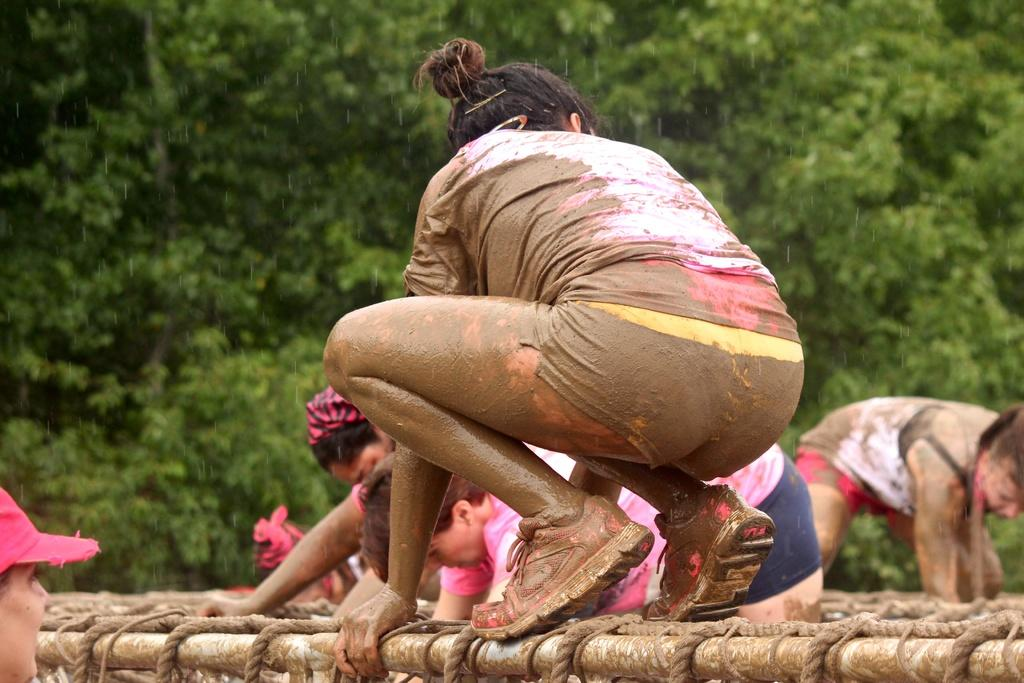What are the persons in the image doing? The persons in the image are playing. In what type of environment are they playing? They are playing in mud. What objects can be seen in the mud? There are rods and threads in the mud. What can be seen in the background of the image? There are trees in the background of the image. What type of cushion can be seen in the image? There is no cushion present in the image. How can the persons in the image be helped to play in a different environment? The question of helping the persons in the image play in a different environment cannot be answered definitively from the provided facts, as it is not related to the image itself. 